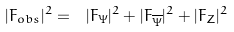<formula> <loc_0><loc_0><loc_500><loc_500>| F _ { o b s } | ^ { 2 } = { \ | F _ { \Psi } | ^ { 2 } + | F _ { \overline { \Psi } } | ^ { 2 } + | F _ { Z } | ^ { 2 } }</formula> 